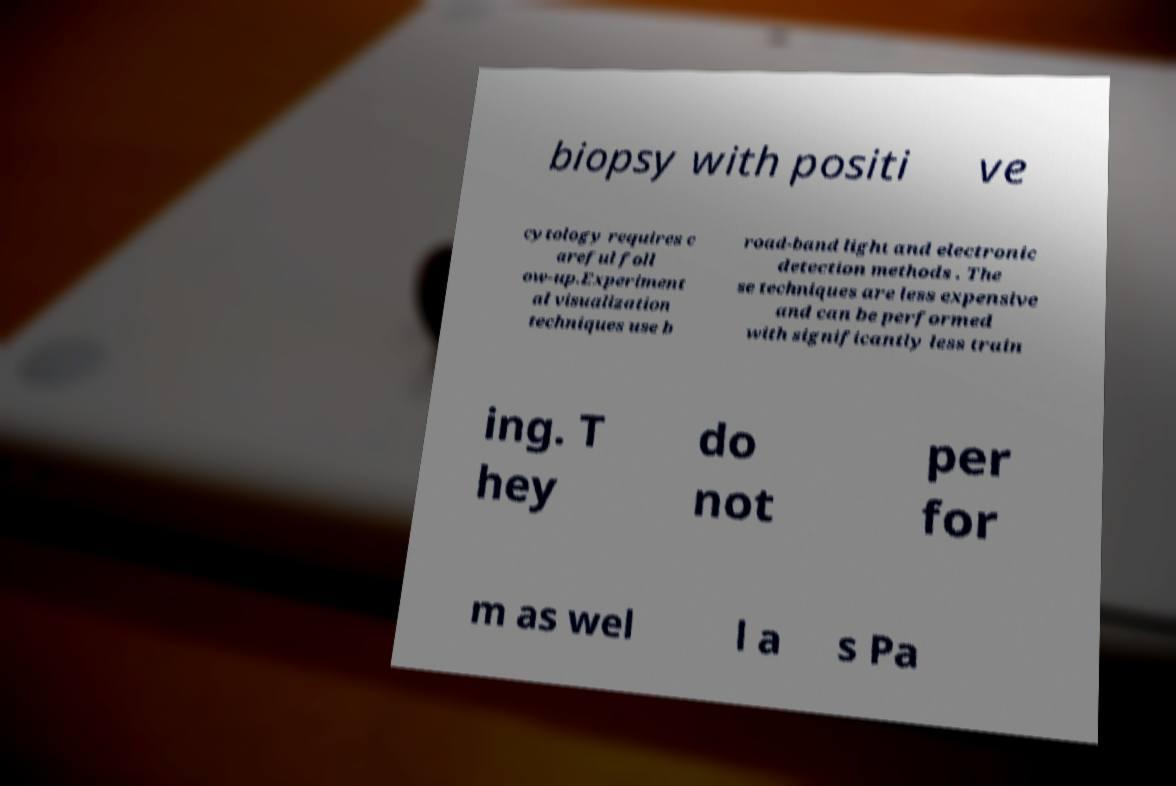Please identify and transcribe the text found in this image. biopsy with positi ve cytology requires c areful foll ow-up.Experiment al visualization techniques use b road-band light and electronic detection methods . The se techniques are less expensive and can be performed with significantly less train ing. T hey do not per for m as wel l a s Pa 